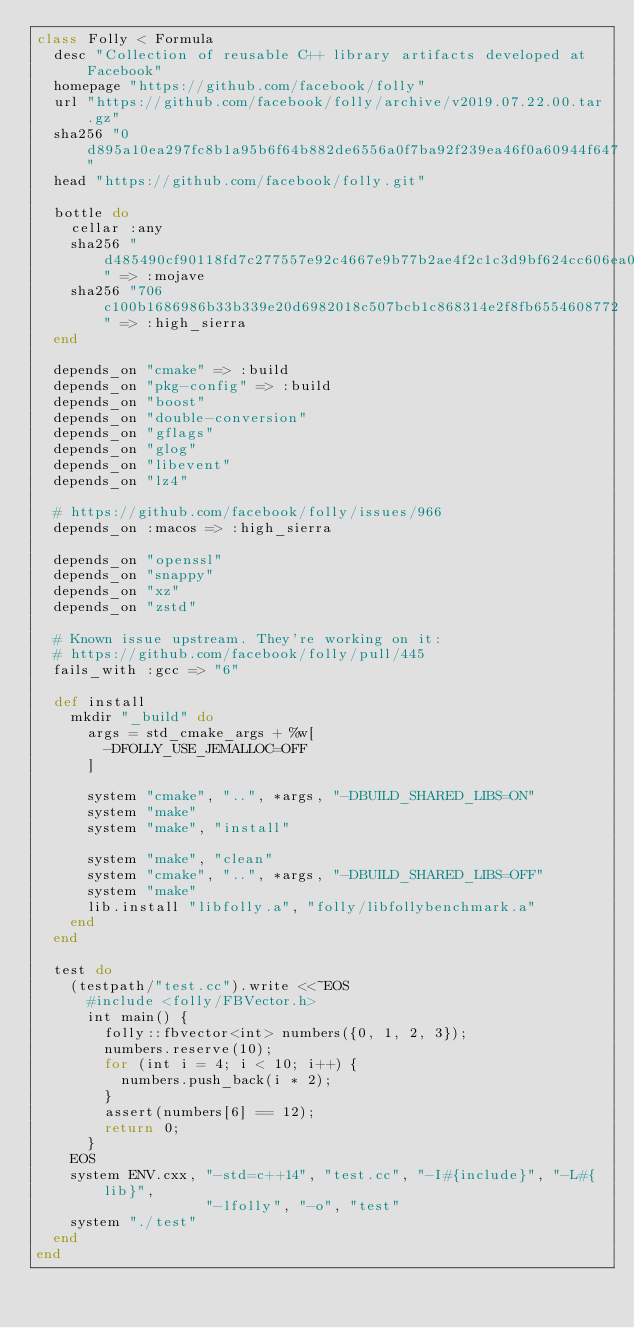<code> <loc_0><loc_0><loc_500><loc_500><_Ruby_>class Folly < Formula
  desc "Collection of reusable C++ library artifacts developed at Facebook"
  homepage "https://github.com/facebook/folly"
  url "https://github.com/facebook/folly/archive/v2019.07.22.00.tar.gz"
  sha256 "0d895a10ea297fc8b1a95b6f64b882de6556a0f7ba92f239ea46f0a60944f647"
  head "https://github.com/facebook/folly.git"

  bottle do
    cellar :any
    sha256 "d485490cf90118fd7c277557e92c4667e9b77b2ae4f2c1c3d9bf624cc606ea05" => :mojave
    sha256 "706c100b1686986b33b339e20d6982018c507bcb1c868314e2f8fb6554608772" => :high_sierra
  end

  depends_on "cmake" => :build
  depends_on "pkg-config" => :build
  depends_on "boost"
  depends_on "double-conversion"
  depends_on "gflags"
  depends_on "glog"
  depends_on "libevent"
  depends_on "lz4"

  # https://github.com/facebook/folly/issues/966
  depends_on :macos => :high_sierra

  depends_on "openssl"
  depends_on "snappy"
  depends_on "xz"
  depends_on "zstd"

  # Known issue upstream. They're working on it:
  # https://github.com/facebook/folly/pull/445
  fails_with :gcc => "6"

  def install
    mkdir "_build" do
      args = std_cmake_args + %w[
        -DFOLLY_USE_JEMALLOC=OFF
      ]

      system "cmake", "..", *args, "-DBUILD_SHARED_LIBS=ON"
      system "make"
      system "make", "install"

      system "make", "clean"
      system "cmake", "..", *args, "-DBUILD_SHARED_LIBS=OFF"
      system "make"
      lib.install "libfolly.a", "folly/libfollybenchmark.a"
    end
  end

  test do
    (testpath/"test.cc").write <<~EOS
      #include <folly/FBVector.h>
      int main() {
        folly::fbvector<int> numbers({0, 1, 2, 3});
        numbers.reserve(10);
        for (int i = 4; i < 10; i++) {
          numbers.push_back(i * 2);
        }
        assert(numbers[6] == 12);
        return 0;
      }
    EOS
    system ENV.cxx, "-std=c++14", "test.cc", "-I#{include}", "-L#{lib}",
                    "-lfolly", "-o", "test"
    system "./test"
  end
end
</code> 